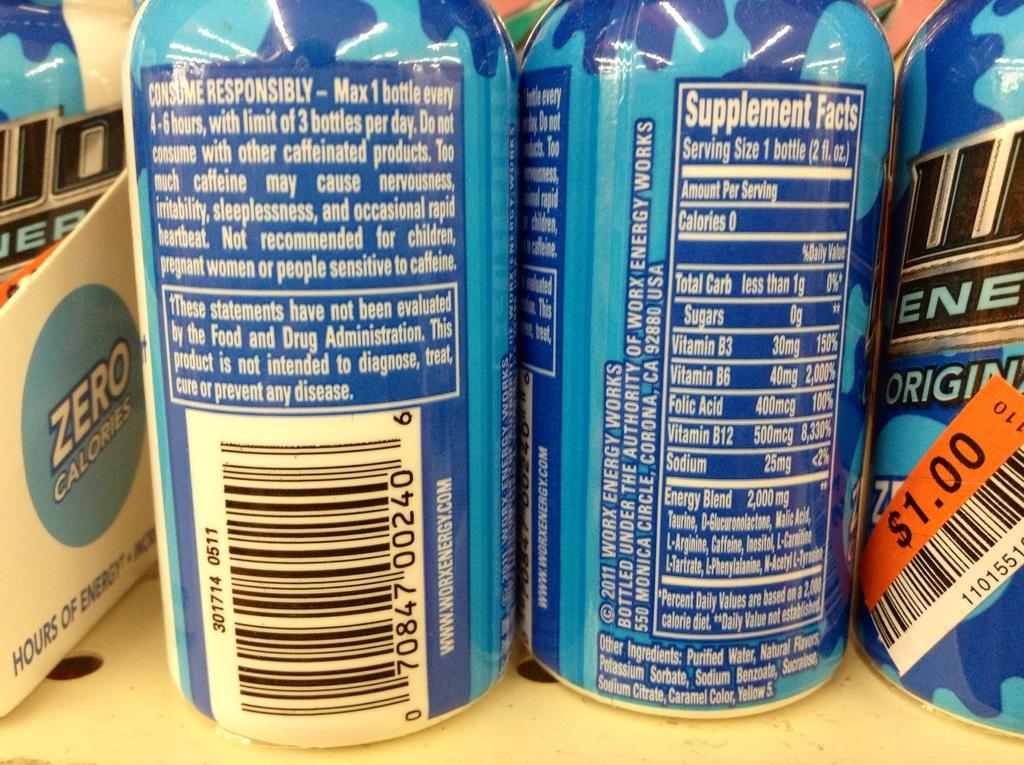<image>
Relay a brief, clear account of the picture shown. close up of cans with the price of $1.00 on one in an orange label 